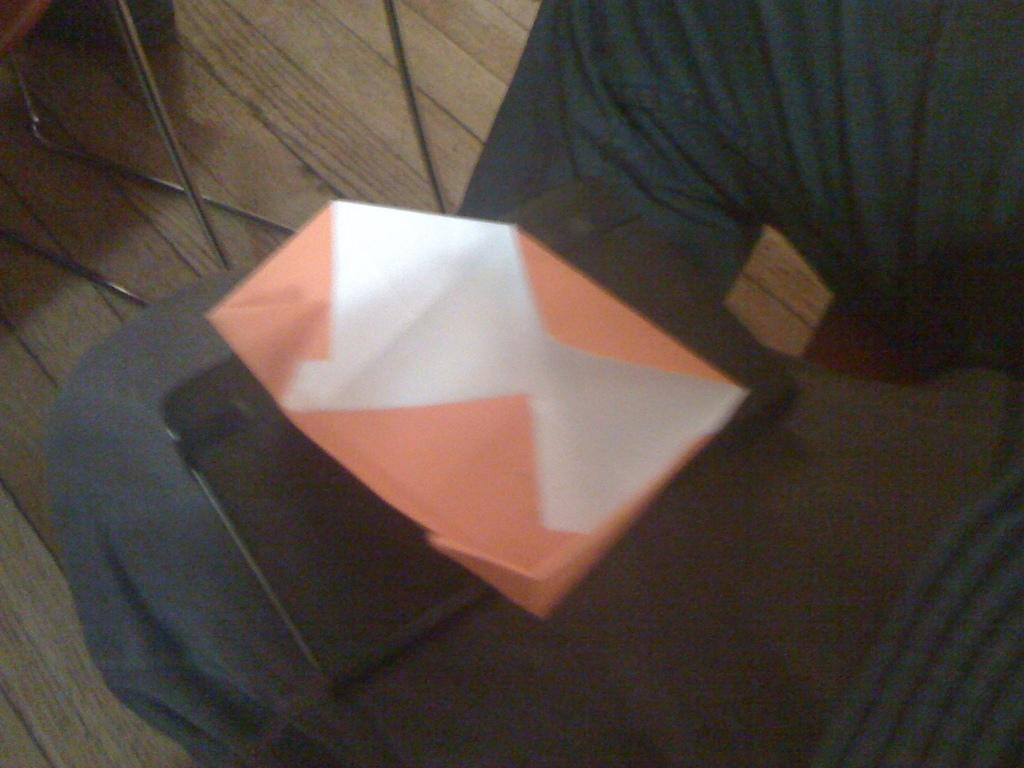What is the main subject of the image? There is a person in the image. Can you describe the person's appearance or clothing? The person has a cover on their leg. What else can be seen on the person's leg? There is an unspecified object on the person's leg. How many frogs can be seen hopping around the person's leg in the image? There are no frogs present in the image. What stage of development is the person in the image? The provided facts do not give any information about the person's developmental stage. 